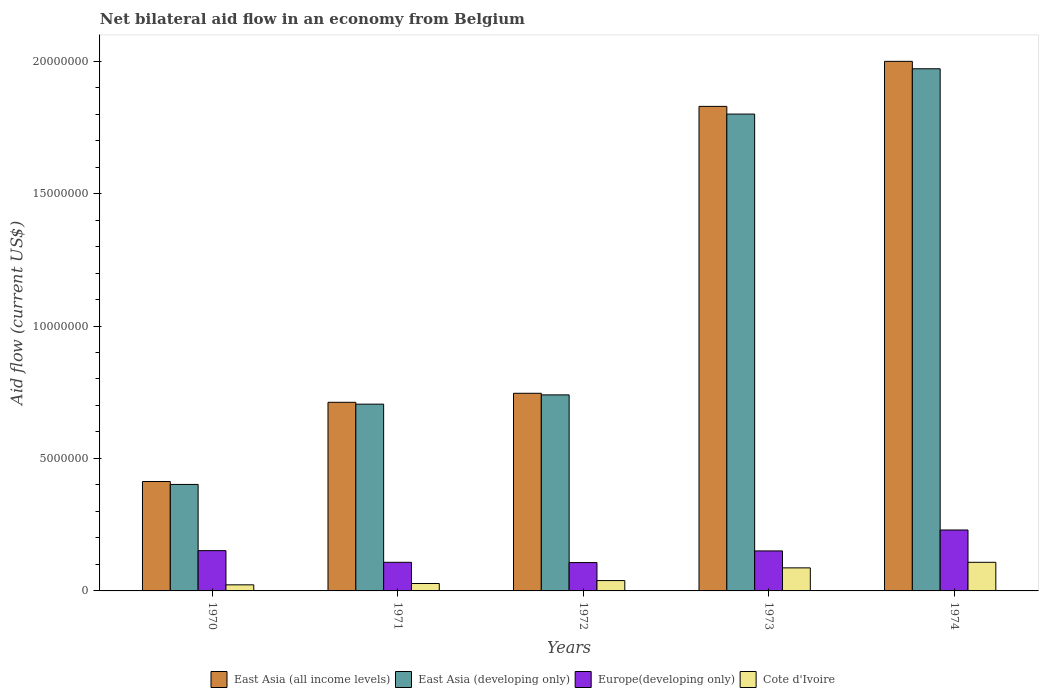How many groups of bars are there?
Keep it short and to the point. 5. How many bars are there on the 1st tick from the left?
Ensure brevity in your answer.  4. How many bars are there on the 4th tick from the right?
Give a very brief answer. 4. What is the net bilateral aid flow in East Asia (all income levels) in 1970?
Offer a terse response. 4.13e+06. Across all years, what is the maximum net bilateral aid flow in Europe(developing only)?
Your response must be concise. 2.30e+06. Across all years, what is the minimum net bilateral aid flow in East Asia (developing only)?
Offer a very short reply. 4.02e+06. In which year was the net bilateral aid flow in Europe(developing only) maximum?
Provide a succinct answer. 1974. What is the total net bilateral aid flow in Cote d'Ivoire in the graph?
Provide a succinct answer. 2.85e+06. What is the difference between the net bilateral aid flow in Cote d'Ivoire in 1970 and that in 1971?
Keep it short and to the point. -5.00e+04. What is the difference between the net bilateral aid flow in Europe(developing only) in 1973 and the net bilateral aid flow in East Asia (all income levels) in 1970?
Your answer should be very brief. -2.62e+06. What is the average net bilateral aid flow in Cote d'Ivoire per year?
Ensure brevity in your answer.  5.70e+05. In the year 1973, what is the difference between the net bilateral aid flow in Cote d'Ivoire and net bilateral aid flow in East Asia (all income levels)?
Your response must be concise. -1.74e+07. In how many years, is the net bilateral aid flow in East Asia (developing only) greater than 3000000 US$?
Give a very brief answer. 5. What is the ratio of the net bilateral aid flow in East Asia (all income levels) in 1971 to that in 1974?
Your answer should be compact. 0.36. What is the difference between the highest and the second highest net bilateral aid flow in Cote d'Ivoire?
Offer a terse response. 2.10e+05. What is the difference between the highest and the lowest net bilateral aid flow in East Asia (all income levels)?
Your response must be concise. 1.59e+07. In how many years, is the net bilateral aid flow in East Asia (all income levels) greater than the average net bilateral aid flow in East Asia (all income levels) taken over all years?
Provide a succinct answer. 2. What does the 4th bar from the left in 1970 represents?
Keep it short and to the point. Cote d'Ivoire. What does the 1st bar from the right in 1971 represents?
Make the answer very short. Cote d'Ivoire. Is it the case that in every year, the sum of the net bilateral aid flow in East Asia (all income levels) and net bilateral aid flow in Europe(developing only) is greater than the net bilateral aid flow in East Asia (developing only)?
Your answer should be very brief. Yes. How many bars are there?
Provide a short and direct response. 20. Are all the bars in the graph horizontal?
Your answer should be very brief. No. How many years are there in the graph?
Your answer should be very brief. 5. Does the graph contain grids?
Your answer should be compact. No. How are the legend labels stacked?
Offer a very short reply. Horizontal. What is the title of the graph?
Offer a very short reply. Net bilateral aid flow in an economy from Belgium. Does "North America" appear as one of the legend labels in the graph?
Your response must be concise. No. What is the label or title of the X-axis?
Make the answer very short. Years. What is the label or title of the Y-axis?
Give a very brief answer. Aid flow (current US$). What is the Aid flow (current US$) of East Asia (all income levels) in 1970?
Make the answer very short. 4.13e+06. What is the Aid flow (current US$) in East Asia (developing only) in 1970?
Make the answer very short. 4.02e+06. What is the Aid flow (current US$) in Europe(developing only) in 1970?
Provide a short and direct response. 1.52e+06. What is the Aid flow (current US$) in Cote d'Ivoire in 1970?
Ensure brevity in your answer.  2.30e+05. What is the Aid flow (current US$) in East Asia (all income levels) in 1971?
Give a very brief answer. 7.12e+06. What is the Aid flow (current US$) of East Asia (developing only) in 1971?
Offer a terse response. 7.05e+06. What is the Aid flow (current US$) of Europe(developing only) in 1971?
Give a very brief answer. 1.08e+06. What is the Aid flow (current US$) of Cote d'Ivoire in 1971?
Give a very brief answer. 2.80e+05. What is the Aid flow (current US$) in East Asia (all income levels) in 1972?
Your answer should be compact. 7.46e+06. What is the Aid flow (current US$) of East Asia (developing only) in 1972?
Offer a terse response. 7.40e+06. What is the Aid flow (current US$) of Europe(developing only) in 1972?
Keep it short and to the point. 1.07e+06. What is the Aid flow (current US$) of Cote d'Ivoire in 1972?
Offer a very short reply. 3.90e+05. What is the Aid flow (current US$) in East Asia (all income levels) in 1973?
Your answer should be compact. 1.83e+07. What is the Aid flow (current US$) of East Asia (developing only) in 1973?
Provide a succinct answer. 1.80e+07. What is the Aid flow (current US$) of Europe(developing only) in 1973?
Offer a very short reply. 1.51e+06. What is the Aid flow (current US$) in Cote d'Ivoire in 1973?
Offer a very short reply. 8.70e+05. What is the Aid flow (current US$) in East Asia (all income levels) in 1974?
Give a very brief answer. 2.00e+07. What is the Aid flow (current US$) of East Asia (developing only) in 1974?
Provide a short and direct response. 1.97e+07. What is the Aid flow (current US$) of Europe(developing only) in 1974?
Offer a very short reply. 2.30e+06. What is the Aid flow (current US$) in Cote d'Ivoire in 1974?
Your answer should be very brief. 1.08e+06. Across all years, what is the maximum Aid flow (current US$) in East Asia (all income levels)?
Provide a succinct answer. 2.00e+07. Across all years, what is the maximum Aid flow (current US$) in East Asia (developing only)?
Offer a very short reply. 1.97e+07. Across all years, what is the maximum Aid flow (current US$) of Europe(developing only)?
Keep it short and to the point. 2.30e+06. Across all years, what is the maximum Aid flow (current US$) in Cote d'Ivoire?
Offer a very short reply. 1.08e+06. Across all years, what is the minimum Aid flow (current US$) of East Asia (all income levels)?
Your answer should be compact. 4.13e+06. Across all years, what is the minimum Aid flow (current US$) of East Asia (developing only)?
Your answer should be very brief. 4.02e+06. Across all years, what is the minimum Aid flow (current US$) in Europe(developing only)?
Your answer should be very brief. 1.07e+06. What is the total Aid flow (current US$) in East Asia (all income levels) in the graph?
Your answer should be very brief. 5.70e+07. What is the total Aid flow (current US$) of East Asia (developing only) in the graph?
Provide a short and direct response. 5.62e+07. What is the total Aid flow (current US$) in Europe(developing only) in the graph?
Ensure brevity in your answer.  7.48e+06. What is the total Aid flow (current US$) in Cote d'Ivoire in the graph?
Offer a very short reply. 2.85e+06. What is the difference between the Aid flow (current US$) in East Asia (all income levels) in 1970 and that in 1971?
Offer a very short reply. -2.99e+06. What is the difference between the Aid flow (current US$) of East Asia (developing only) in 1970 and that in 1971?
Provide a succinct answer. -3.03e+06. What is the difference between the Aid flow (current US$) of Cote d'Ivoire in 1970 and that in 1971?
Your answer should be compact. -5.00e+04. What is the difference between the Aid flow (current US$) of East Asia (all income levels) in 1970 and that in 1972?
Provide a short and direct response. -3.33e+06. What is the difference between the Aid flow (current US$) of East Asia (developing only) in 1970 and that in 1972?
Make the answer very short. -3.38e+06. What is the difference between the Aid flow (current US$) of Cote d'Ivoire in 1970 and that in 1972?
Your answer should be very brief. -1.60e+05. What is the difference between the Aid flow (current US$) of East Asia (all income levels) in 1970 and that in 1973?
Your response must be concise. -1.42e+07. What is the difference between the Aid flow (current US$) in East Asia (developing only) in 1970 and that in 1973?
Keep it short and to the point. -1.40e+07. What is the difference between the Aid flow (current US$) of Europe(developing only) in 1970 and that in 1973?
Offer a terse response. 10000. What is the difference between the Aid flow (current US$) in Cote d'Ivoire in 1970 and that in 1973?
Provide a short and direct response. -6.40e+05. What is the difference between the Aid flow (current US$) in East Asia (all income levels) in 1970 and that in 1974?
Keep it short and to the point. -1.59e+07. What is the difference between the Aid flow (current US$) of East Asia (developing only) in 1970 and that in 1974?
Make the answer very short. -1.57e+07. What is the difference between the Aid flow (current US$) in Europe(developing only) in 1970 and that in 1974?
Provide a short and direct response. -7.80e+05. What is the difference between the Aid flow (current US$) of Cote d'Ivoire in 1970 and that in 1974?
Ensure brevity in your answer.  -8.50e+05. What is the difference between the Aid flow (current US$) in East Asia (developing only) in 1971 and that in 1972?
Your answer should be compact. -3.50e+05. What is the difference between the Aid flow (current US$) of Europe(developing only) in 1971 and that in 1972?
Offer a very short reply. 10000. What is the difference between the Aid flow (current US$) in Cote d'Ivoire in 1971 and that in 1972?
Your answer should be very brief. -1.10e+05. What is the difference between the Aid flow (current US$) in East Asia (all income levels) in 1971 and that in 1973?
Ensure brevity in your answer.  -1.12e+07. What is the difference between the Aid flow (current US$) of East Asia (developing only) in 1971 and that in 1973?
Make the answer very short. -1.10e+07. What is the difference between the Aid flow (current US$) of Europe(developing only) in 1971 and that in 1973?
Ensure brevity in your answer.  -4.30e+05. What is the difference between the Aid flow (current US$) of Cote d'Ivoire in 1971 and that in 1973?
Make the answer very short. -5.90e+05. What is the difference between the Aid flow (current US$) of East Asia (all income levels) in 1971 and that in 1974?
Provide a short and direct response. -1.29e+07. What is the difference between the Aid flow (current US$) of East Asia (developing only) in 1971 and that in 1974?
Provide a succinct answer. -1.27e+07. What is the difference between the Aid flow (current US$) of Europe(developing only) in 1971 and that in 1974?
Provide a succinct answer. -1.22e+06. What is the difference between the Aid flow (current US$) of Cote d'Ivoire in 1971 and that in 1974?
Your answer should be very brief. -8.00e+05. What is the difference between the Aid flow (current US$) of East Asia (all income levels) in 1972 and that in 1973?
Your response must be concise. -1.08e+07. What is the difference between the Aid flow (current US$) in East Asia (developing only) in 1972 and that in 1973?
Provide a succinct answer. -1.06e+07. What is the difference between the Aid flow (current US$) in Europe(developing only) in 1972 and that in 1973?
Give a very brief answer. -4.40e+05. What is the difference between the Aid flow (current US$) of Cote d'Ivoire in 1972 and that in 1973?
Provide a succinct answer. -4.80e+05. What is the difference between the Aid flow (current US$) of East Asia (all income levels) in 1972 and that in 1974?
Your answer should be very brief. -1.25e+07. What is the difference between the Aid flow (current US$) in East Asia (developing only) in 1972 and that in 1974?
Give a very brief answer. -1.23e+07. What is the difference between the Aid flow (current US$) of Europe(developing only) in 1972 and that in 1974?
Your response must be concise. -1.23e+06. What is the difference between the Aid flow (current US$) of Cote d'Ivoire in 1972 and that in 1974?
Your answer should be very brief. -6.90e+05. What is the difference between the Aid flow (current US$) of East Asia (all income levels) in 1973 and that in 1974?
Provide a succinct answer. -1.70e+06. What is the difference between the Aid flow (current US$) of East Asia (developing only) in 1973 and that in 1974?
Offer a terse response. -1.71e+06. What is the difference between the Aid flow (current US$) of Europe(developing only) in 1973 and that in 1974?
Give a very brief answer. -7.90e+05. What is the difference between the Aid flow (current US$) of East Asia (all income levels) in 1970 and the Aid flow (current US$) of East Asia (developing only) in 1971?
Ensure brevity in your answer.  -2.92e+06. What is the difference between the Aid flow (current US$) of East Asia (all income levels) in 1970 and the Aid flow (current US$) of Europe(developing only) in 1971?
Offer a very short reply. 3.05e+06. What is the difference between the Aid flow (current US$) of East Asia (all income levels) in 1970 and the Aid flow (current US$) of Cote d'Ivoire in 1971?
Offer a very short reply. 3.85e+06. What is the difference between the Aid flow (current US$) of East Asia (developing only) in 1970 and the Aid flow (current US$) of Europe(developing only) in 1971?
Your answer should be compact. 2.94e+06. What is the difference between the Aid flow (current US$) in East Asia (developing only) in 1970 and the Aid flow (current US$) in Cote d'Ivoire in 1971?
Your answer should be very brief. 3.74e+06. What is the difference between the Aid flow (current US$) of Europe(developing only) in 1970 and the Aid flow (current US$) of Cote d'Ivoire in 1971?
Give a very brief answer. 1.24e+06. What is the difference between the Aid flow (current US$) in East Asia (all income levels) in 1970 and the Aid flow (current US$) in East Asia (developing only) in 1972?
Your response must be concise. -3.27e+06. What is the difference between the Aid flow (current US$) in East Asia (all income levels) in 1970 and the Aid flow (current US$) in Europe(developing only) in 1972?
Provide a short and direct response. 3.06e+06. What is the difference between the Aid flow (current US$) in East Asia (all income levels) in 1970 and the Aid flow (current US$) in Cote d'Ivoire in 1972?
Give a very brief answer. 3.74e+06. What is the difference between the Aid flow (current US$) in East Asia (developing only) in 1970 and the Aid flow (current US$) in Europe(developing only) in 1972?
Your answer should be compact. 2.95e+06. What is the difference between the Aid flow (current US$) in East Asia (developing only) in 1970 and the Aid flow (current US$) in Cote d'Ivoire in 1972?
Offer a very short reply. 3.63e+06. What is the difference between the Aid flow (current US$) of Europe(developing only) in 1970 and the Aid flow (current US$) of Cote d'Ivoire in 1972?
Your response must be concise. 1.13e+06. What is the difference between the Aid flow (current US$) of East Asia (all income levels) in 1970 and the Aid flow (current US$) of East Asia (developing only) in 1973?
Provide a short and direct response. -1.39e+07. What is the difference between the Aid flow (current US$) in East Asia (all income levels) in 1970 and the Aid flow (current US$) in Europe(developing only) in 1973?
Give a very brief answer. 2.62e+06. What is the difference between the Aid flow (current US$) in East Asia (all income levels) in 1970 and the Aid flow (current US$) in Cote d'Ivoire in 1973?
Your answer should be very brief. 3.26e+06. What is the difference between the Aid flow (current US$) in East Asia (developing only) in 1970 and the Aid flow (current US$) in Europe(developing only) in 1973?
Your answer should be very brief. 2.51e+06. What is the difference between the Aid flow (current US$) of East Asia (developing only) in 1970 and the Aid flow (current US$) of Cote d'Ivoire in 1973?
Make the answer very short. 3.15e+06. What is the difference between the Aid flow (current US$) in Europe(developing only) in 1970 and the Aid flow (current US$) in Cote d'Ivoire in 1973?
Provide a short and direct response. 6.50e+05. What is the difference between the Aid flow (current US$) in East Asia (all income levels) in 1970 and the Aid flow (current US$) in East Asia (developing only) in 1974?
Offer a very short reply. -1.56e+07. What is the difference between the Aid flow (current US$) of East Asia (all income levels) in 1970 and the Aid flow (current US$) of Europe(developing only) in 1974?
Ensure brevity in your answer.  1.83e+06. What is the difference between the Aid flow (current US$) of East Asia (all income levels) in 1970 and the Aid flow (current US$) of Cote d'Ivoire in 1974?
Your answer should be compact. 3.05e+06. What is the difference between the Aid flow (current US$) of East Asia (developing only) in 1970 and the Aid flow (current US$) of Europe(developing only) in 1974?
Give a very brief answer. 1.72e+06. What is the difference between the Aid flow (current US$) in East Asia (developing only) in 1970 and the Aid flow (current US$) in Cote d'Ivoire in 1974?
Keep it short and to the point. 2.94e+06. What is the difference between the Aid flow (current US$) of East Asia (all income levels) in 1971 and the Aid flow (current US$) of East Asia (developing only) in 1972?
Your response must be concise. -2.80e+05. What is the difference between the Aid flow (current US$) of East Asia (all income levels) in 1971 and the Aid flow (current US$) of Europe(developing only) in 1972?
Ensure brevity in your answer.  6.05e+06. What is the difference between the Aid flow (current US$) of East Asia (all income levels) in 1971 and the Aid flow (current US$) of Cote d'Ivoire in 1972?
Provide a succinct answer. 6.73e+06. What is the difference between the Aid flow (current US$) of East Asia (developing only) in 1971 and the Aid flow (current US$) of Europe(developing only) in 1972?
Give a very brief answer. 5.98e+06. What is the difference between the Aid flow (current US$) of East Asia (developing only) in 1971 and the Aid flow (current US$) of Cote d'Ivoire in 1972?
Your answer should be very brief. 6.66e+06. What is the difference between the Aid flow (current US$) in Europe(developing only) in 1971 and the Aid flow (current US$) in Cote d'Ivoire in 1972?
Provide a short and direct response. 6.90e+05. What is the difference between the Aid flow (current US$) in East Asia (all income levels) in 1971 and the Aid flow (current US$) in East Asia (developing only) in 1973?
Your answer should be compact. -1.09e+07. What is the difference between the Aid flow (current US$) of East Asia (all income levels) in 1971 and the Aid flow (current US$) of Europe(developing only) in 1973?
Offer a terse response. 5.61e+06. What is the difference between the Aid flow (current US$) in East Asia (all income levels) in 1971 and the Aid flow (current US$) in Cote d'Ivoire in 1973?
Provide a succinct answer. 6.25e+06. What is the difference between the Aid flow (current US$) of East Asia (developing only) in 1971 and the Aid flow (current US$) of Europe(developing only) in 1973?
Make the answer very short. 5.54e+06. What is the difference between the Aid flow (current US$) in East Asia (developing only) in 1971 and the Aid flow (current US$) in Cote d'Ivoire in 1973?
Provide a short and direct response. 6.18e+06. What is the difference between the Aid flow (current US$) of East Asia (all income levels) in 1971 and the Aid flow (current US$) of East Asia (developing only) in 1974?
Give a very brief answer. -1.26e+07. What is the difference between the Aid flow (current US$) of East Asia (all income levels) in 1971 and the Aid flow (current US$) of Europe(developing only) in 1974?
Offer a terse response. 4.82e+06. What is the difference between the Aid flow (current US$) of East Asia (all income levels) in 1971 and the Aid flow (current US$) of Cote d'Ivoire in 1974?
Keep it short and to the point. 6.04e+06. What is the difference between the Aid flow (current US$) of East Asia (developing only) in 1971 and the Aid flow (current US$) of Europe(developing only) in 1974?
Offer a terse response. 4.75e+06. What is the difference between the Aid flow (current US$) in East Asia (developing only) in 1971 and the Aid flow (current US$) in Cote d'Ivoire in 1974?
Your response must be concise. 5.97e+06. What is the difference between the Aid flow (current US$) of Europe(developing only) in 1971 and the Aid flow (current US$) of Cote d'Ivoire in 1974?
Give a very brief answer. 0. What is the difference between the Aid flow (current US$) of East Asia (all income levels) in 1972 and the Aid flow (current US$) of East Asia (developing only) in 1973?
Your answer should be compact. -1.05e+07. What is the difference between the Aid flow (current US$) in East Asia (all income levels) in 1972 and the Aid flow (current US$) in Europe(developing only) in 1973?
Provide a short and direct response. 5.95e+06. What is the difference between the Aid flow (current US$) of East Asia (all income levels) in 1972 and the Aid flow (current US$) of Cote d'Ivoire in 1973?
Your response must be concise. 6.59e+06. What is the difference between the Aid flow (current US$) of East Asia (developing only) in 1972 and the Aid flow (current US$) of Europe(developing only) in 1973?
Your answer should be compact. 5.89e+06. What is the difference between the Aid flow (current US$) in East Asia (developing only) in 1972 and the Aid flow (current US$) in Cote d'Ivoire in 1973?
Ensure brevity in your answer.  6.53e+06. What is the difference between the Aid flow (current US$) of Europe(developing only) in 1972 and the Aid flow (current US$) of Cote d'Ivoire in 1973?
Your response must be concise. 2.00e+05. What is the difference between the Aid flow (current US$) of East Asia (all income levels) in 1972 and the Aid flow (current US$) of East Asia (developing only) in 1974?
Make the answer very short. -1.22e+07. What is the difference between the Aid flow (current US$) in East Asia (all income levels) in 1972 and the Aid flow (current US$) in Europe(developing only) in 1974?
Provide a short and direct response. 5.16e+06. What is the difference between the Aid flow (current US$) of East Asia (all income levels) in 1972 and the Aid flow (current US$) of Cote d'Ivoire in 1974?
Your response must be concise. 6.38e+06. What is the difference between the Aid flow (current US$) of East Asia (developing only) in 1972 and the Aid flow (current US$) of Europe(developing only) in 1974?
Your answer should be very brief. 5.10e+06. What is the difference between the Aid flow (current US$) of East Asia (developing only) in 1972 and the Aid flow (current US$) of Cote d'Ivoire in 1974?
Your answer should be very brief. 6.32e+06. What is the difference between the Aid flow (current US$) in East Asia (all income levels) in 1973 and the Aid flow (current US$) in East Asia (developing only) in 1974?
Your response must be concise. -1.42e+06. What is the difference between the Aid flow (current US$) of East Asia (all income levels) in 1973 and the Aid flow (current US$) of Europe(developing only) in 1974?
Your response must be concise. 1.60e+07. What is the difference between the Aid flow (current US$) in East Asia (all income levels) in 1973 and the Aid flow (current US$) in Cote d'Ivoire in 1974?
Make the answer very short. 1.72e+07. What is the difference between the Aid flow (current US$) in East Asia (developing only) in 1973 and the Aid flow (current US$) in Europe(developing only) in 1974?
Offer a terse response. 1.57e+07. What is the difference between the Aid flow (current US$) in East Asia (developing only) in 1973 and the Aid flow (current US$) in Cote d'Ivoire in 1974?
Your answer should be compact. 1.69e+07. What is the average Aid flow (current US$) in East Asia (all income levels) per year?
Keep it short and to the point. 1.14e+07. What is the average Aid flow (current US$) in East Asia (developing only) per year?
Provide a short and direct response. 1.12e+07. What is the average Aid flow (current US$) in Europe(developing only) per year?
Your answer should be compact. 1.50e+06. What is the average Aid flow (current US$) in Cote d'Ivoire per year?
Provide a succinct answer. 5.70e+05. In the year 1970, what is the difference between the Aid flow (current US$) of East Asia (all income levels) and Aid flow (current US$) of East Asia (developing only)?
Give a very brief answer. 1.10e+05. In the year 1970, what is the difference between the Aid flow (current US$) in East Asia (all income levels) and Aid flow (current US$) in Europe(developing only)?
Offer a terse response. 2.61e+06. In the year 1970, what is the difference between the Aid flow (current US$) of East Asia (all income levels) and Aid flow (current US$) of Cote d'Ivoire?
Provide a succinct answer. 3.90e+06. In the year 1970, what is the difference between the Aid flow (current US$) in East Asia (developing only) and Aid flow (current US$) in Europe(developing only)?
Keep it short and to the point. 2.50e+06. In the year 1970, what is the difference between the Aid flow (current US$) of East Asia (developing only) and Aid flow (current US$) of Cote d'Ivoire?
Give a very brief answer. 3.79e+06. In the year 1970, what is the difference between the Aid flow (current US$) in Europe(developing only) and Aid flow (current US$) in Cote d'Ivoire?
Keep it short and to the point. 1.29e+06. In the year 1971, what is the difference between the Aid flow (current US$) in East Asia (all income levels) and Aid flow (current US$) in Europe(developing only)?
Give a very brief answer. 6.04e+06. In the year 1971, what is the difference between the Aid flow (current US$) in East Asia (all income levels) and Aid flow (current US$) in Cote d'Ivoire?
Ensure brevity in your answer.  6.84e+06. In the year 1971, what is the difference between the Aid flow (current US$) in East Asia (developing only) and Aid flow (current US$) in Europe(developing only)?
Give a very brief answer. 5.97e+06. In the year 1971, what is the difference between the Aid flow (current US$) in East Asia (developing only) and Aid flow (current US$) in Cote d'Ivoire?
Provide a succinct answer. 6.77e+06. In the year 1972, what is the difference between the Aid flow (current US$) of East Asia (all income levels) and Aid flow (current US$) of Europe(developing only)?
Make the answer very short. 6.39e+06. In the year 1972, what is the difference between the Aid flow (current US$) in East Asia (all income levels) and Aid flow (current US$) in Cote d'Ivoire?
Offer a terse response. 7.07e+06. In the year 1972, what is the difference between the Aid flow (current US$) of East Asia (developing only) and Aid flow (current US$) of Europe(developing only)?
Your answer should be very brief. 6.33e+06. In the year 1972, what is the difference between the Aid flow (current US$) in East Asia (developing only) and Aid flow (current US$) in Cote d'Ivoire?
Your answer should be very brief. 7.01e+06. In the year 1972, what is the difference between the Aid flow (current US$) of Europe(developing only) and Aid flow (current US$) of Cote d'Ivoire?
Your answer should be very brief. 6.80e+05. In the year 1973, what is the difference between the Aid flow (current US$) in East Asia (all income levels) and Aid flow (current US$) in East Asia (developing only)?
Ensure brevity in your answer.  2.90e+05. In the year 1973, what is the difference between the Aid flow (current US$) in East Asia (all income levels) and Aid flow (current US$) in Europe(developing only)?
Ensure brevity in your answer.  1.68e+07. In the year 1973, what is the difference between the Aid flow (current US$) of East Asia (all income levels) and Aid flow (current US$) of Cote d'Ivoire?
Your answer should be compact. 1.74e+07. In the year 1973, what is the difference between the Aid flow (current US$) in East Asia (developing only) and Aid flow (current US$) in Europe(developing only)?
Your answer should be compact. 1.65e+07. In the year 1973, what is the difference between the Aid flow (current US$) of East Asia (developing only) and Aid flow (current US$) of Cote d'Ivoire?
Offer a terse response. 1.71e+07. In the year 1973, what is the difference between the Aid flow (current US$) in Europe(developing only) and Aid flow (current US$) in Cote d'Ivoire?
Make the answer very short. 6.40e+05. In the year 1974, what is the difference between the Aid flow (current US$) in East Asia (all income levels) and Aid flow (current US$) in Europe(developing only)?
Ensure brevity in your answer.  1.77e+07. In the year 1974, what is the difference between the Aid flow (current US$) of East Asia (all income levels) and Aid flow (current US$) of Cote d'Ivoire?
Give a very brief answer. 1.89e+07. In the year 1974, what is the difference between the Aid flow (current US$) in East Asia (developing only) and Aid flow (current US$) in Europe(developing only)?
Keep it short and to the point. 1.74e+07. In the year 1974, what is the difference between the Aid flow (current US$) in East Asia (developing only) and Aid flow (current US$) in Cote d'Ivoire?
Ensure brevity in your answer.  1.86e+07. In the year 1974, what is the difference between the Aid flow (current US$) of Europe(developing only) and Aid flow (current US$) of Cote d'Ivoire?
Make the answer very short. 1.22e+06. What is the ratio of the Aid flow (current US$) in East Asia (all income levels) in 1970 to that in 1971?
Make the answer very short. 0.58. What is the ratio of the Aid flow (current US$) of East Asia (developing only) in 1970 to that in 1971?
Make the answer very short. 0.57. What is the ratio of the Aid flow (current US$) of Europe(developing only) in 1970 to that in 1971?
Provide a succinct answer. 1.41. What is the ratio of the Aid flow (current US$) in Cote d'Ivoire in 1970 to that in 1971?
Offer a very short reply. 0.82. What is the ratio of the Aid flow (current US$) in East Asia (all income levels) in 1970 to that in 1972?
Provide a succinct answer. 0.55. What is the ratio of the Aid flow (current US$) in East Asia (developing only) in 1970 to that in 1972?
Give a very brief answer. 0.54. What is the ratio of the Aid flow (current US$) in Europe(developing only) in 1970 to that in 1972?
Your answer should be very brief. 1.42. What is the ratio of the Aid flow (current US$) in Cote d'Ivoire in 1970 to that in 1972?
Give a very brief answer. 0.59. What is the ratio of the Aid flow (current US$) in East Asia (all income levels) in 1970 to that in 1973?
Give a very brief answer. 0.23. What is the ratio of the Aid flow (current US$) in East Asia (developing only) in 1970 to that in 1973?
Your answer should be compact. 0.22. What is the ratio of the Aid flow (current US$) of Europe(developing only) in 1970 to that in 1973?
Your response must be concise. 1.01. What is the ratio of the Aid flow (current US$) of Cote d'Ivoire in 1970 to that in 1973?
Provide a short and direct response. 0.26. What is the ratio of the Aid flow (current US$) in East Asia (all income levels) in 1970 to that in 1974?
Make the answer very short. 0.21. What is the ratio of the Aid flow (current US$) in East Asia (developing only) in 1970 to that in 1974?
Keep it short and to the point. 0.2. What is the ratio of the Aid flow (current US$) in Europe(developing only) in 1970 to that in 1974?
Make the answer very short. 0.66. What is the ratio of the Aid flow (current US$) of Cote d'Ivoire in 1970 to that in 1974?
Keep it short and to the point. 0.21. What is the ratio of the Aid flow (current US$) in East Asia (all income levels) in 1971 to that in 1972?
Your answer should be very brief. 0.95. What is the ratio of the Aid flow (current US$) of East Asia (developing only) in 1971 to that in 1972?
Your answer should be compact. 0.95. What is the ratio of the Aid flow (current US$) of Europe(developing only) in 1971 to that in 1972?
Give a very brief answer. 1.01. What is the ratio of the Aid flow (current US$) of Cote d'Ivoire in 1971 to that in 1972?
Your answer should be compact. 0.72. What is the ratio of the Aid flow (current US$) of East Asia (all income levels) in 1971 to that in 1973?
Keep it short and to the point. 0.39. What is the ratio of the Aid flow (current US$) of East Asia (developing only) in 1971 to that in 1973?
Your answer should be very brief. 0.39. What is the ratio of the Aid flow (current US$) of Europe(developing only) in 1971 to that in 1973?
Offer a terse response. 0.72. What is the ratio of the Aid flow (current US$) of Cote d'Ivoire in 1971 to that in 1973?
Your response must be concise. 0.32. What is the ratio of the Aid flow (current US$) of East Asia (all income levels) in 1971 to that in 1974?
Your response must be concise. 0.36. What is the ratio of the Aid flow (current US$) of East Asia (developing only) in 1971 to that in 1974?
Your response must be concise. 0.36. What is the ratio of the Aid flow (current US$) in Europe(developing only) in 1971 to that in 1974?
Provide a succinct answer. 0.47. What is the ratio of the Aid flow (current US$) in Cote d'Ivoire in 1971 to that in 1974?
Provide a short and direct response. 0.26. What is the ratio of the Aid flow (current US$) in East Asia (all income levels) in 1972 to that in 1973?
Offer a terse response. 0.41. What is the ratio of the Aid flow (current US$) of East Asia (developing only) in 1972 to that in 1973?
Offer a very short reply. 0.41. What is the ratio of the Aid flow (current US$) in Europe(developing only) in 1972 to that in 1973?
Ensure brevity in your answer.  0.71. What is the ratio of the Aid flow (current US$) in Cote d'Ivoire in 1972 to that in 1973?
Offer a terse response. 0.45. What is the ratio of the Aid flow (current US$) of East Asia (all income levels) in 1972 to that in 1974?
Your response must be concise. 0.37. What is the ratio of the Aid flow (current US$) of East Asia (developing only) in 1972 to that in 1974?
Your answer should be compact. 0.38. What is the ratio of the Aid flow (current US$) in Europe(developing only) in 1972 to that in 1974?
Provide a short and direct response. 0.47. What is the ratio of the Aid flow (current US$) in Cote d'Ivoire in 1972 to that in 1974?
Offer a terse response. 0.36. What is the ratio of the Aid flow (current US$) of East Asia (all income levels) in 1973 to that in 1974?
Provide a short and direct response. 0.92. What is the ratio of the Aid flow (current US$) of East Asia (developing only) in 1973 to that in 1974?
Provide a succinct answer. 0.91. What is the ratio of the Aid flow (current US$) of Europe(developing only) in 1973 to that in 1974?
Provide a short and direct response. 0.66. What is the ratio of the Aid flow (current US$) in Cote d'Ivoire in 1973 to that in 1974?
Offer a terse response. 0.81. What is the difference between the highest and the second highest Aid flow (current US$) of East Asia (all income levels)?
Provide a succinct answer. 1.70e+06. What is the difference between the highest and the second highest Aid flow (current US$) in East Asia (developing only)?
Your answer should be compact. 1.71e+06. What is the difference between the highest and the second highest Aid flow (current US$) of Europe(developing only)?
Ensure brevity in your answer.  7.80e+05. What is the difference between the highest and the lowest Aid flow (current US$) in East Asia (all income levels)?
Provide a succinct answer. 1.59e+07. What is the difference between the highest and the lowest Aid flow (current US$) in East Asia (developing only)?
Give a very brief answer. 1.57e+07. What is the difference between the highest and the lowest Aid flow (current US$) of Europe(developing only)?
Ensure brevity in your answer.  1.23e+06. What is the difference between the highest and the lowest Aid flow (current US$) in Cote d'Ivoire?
Your response must be concise. 8.50e+05. 